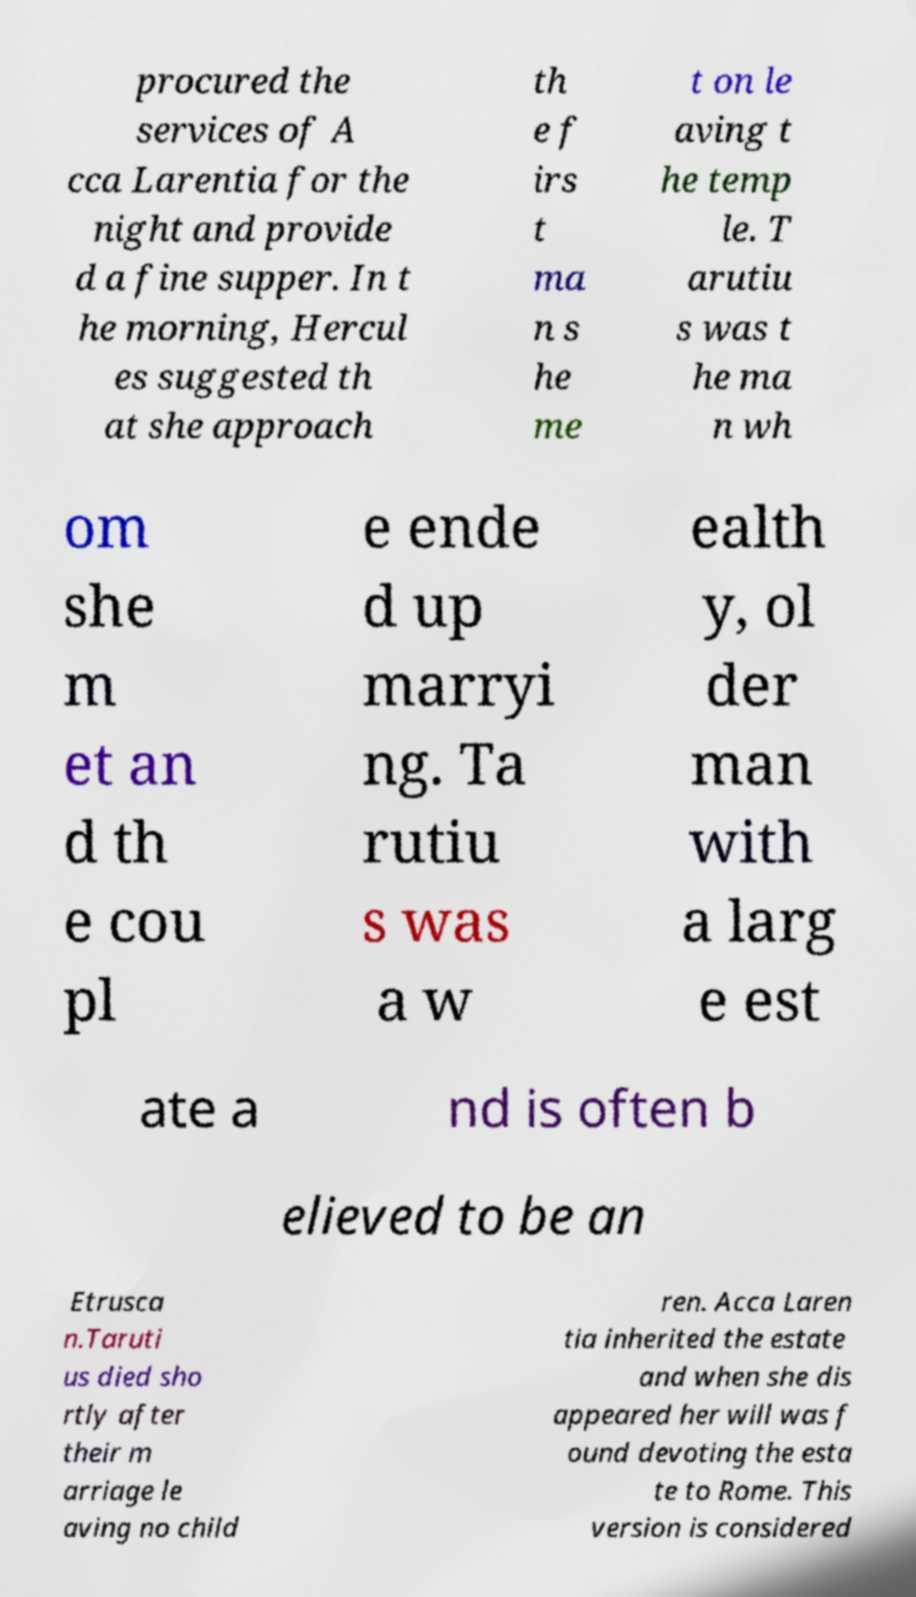I need the written content from this picture converted into text. Can you do that? procured the services of A cca Larentia for the night and provide d a fine supper. In t he morning, Hercul es suggested th at she approach th e f irs t ma n s he me t on le aving t he temp le. T arutiu s was t he ma n wh om she m et an d th e cou pl e ende d up marryi ng. Ta rutiu s was a w ealth y, ol der man with a larg e est ate a nd is often b elieved to be an Etrusca n.Taruti us died sho rtly after their m arriage le aving no child ren. Acca Laren tia inherited the estate and when she dis appeared her will was f ound devoting the esta te to Rome. This version is considered 